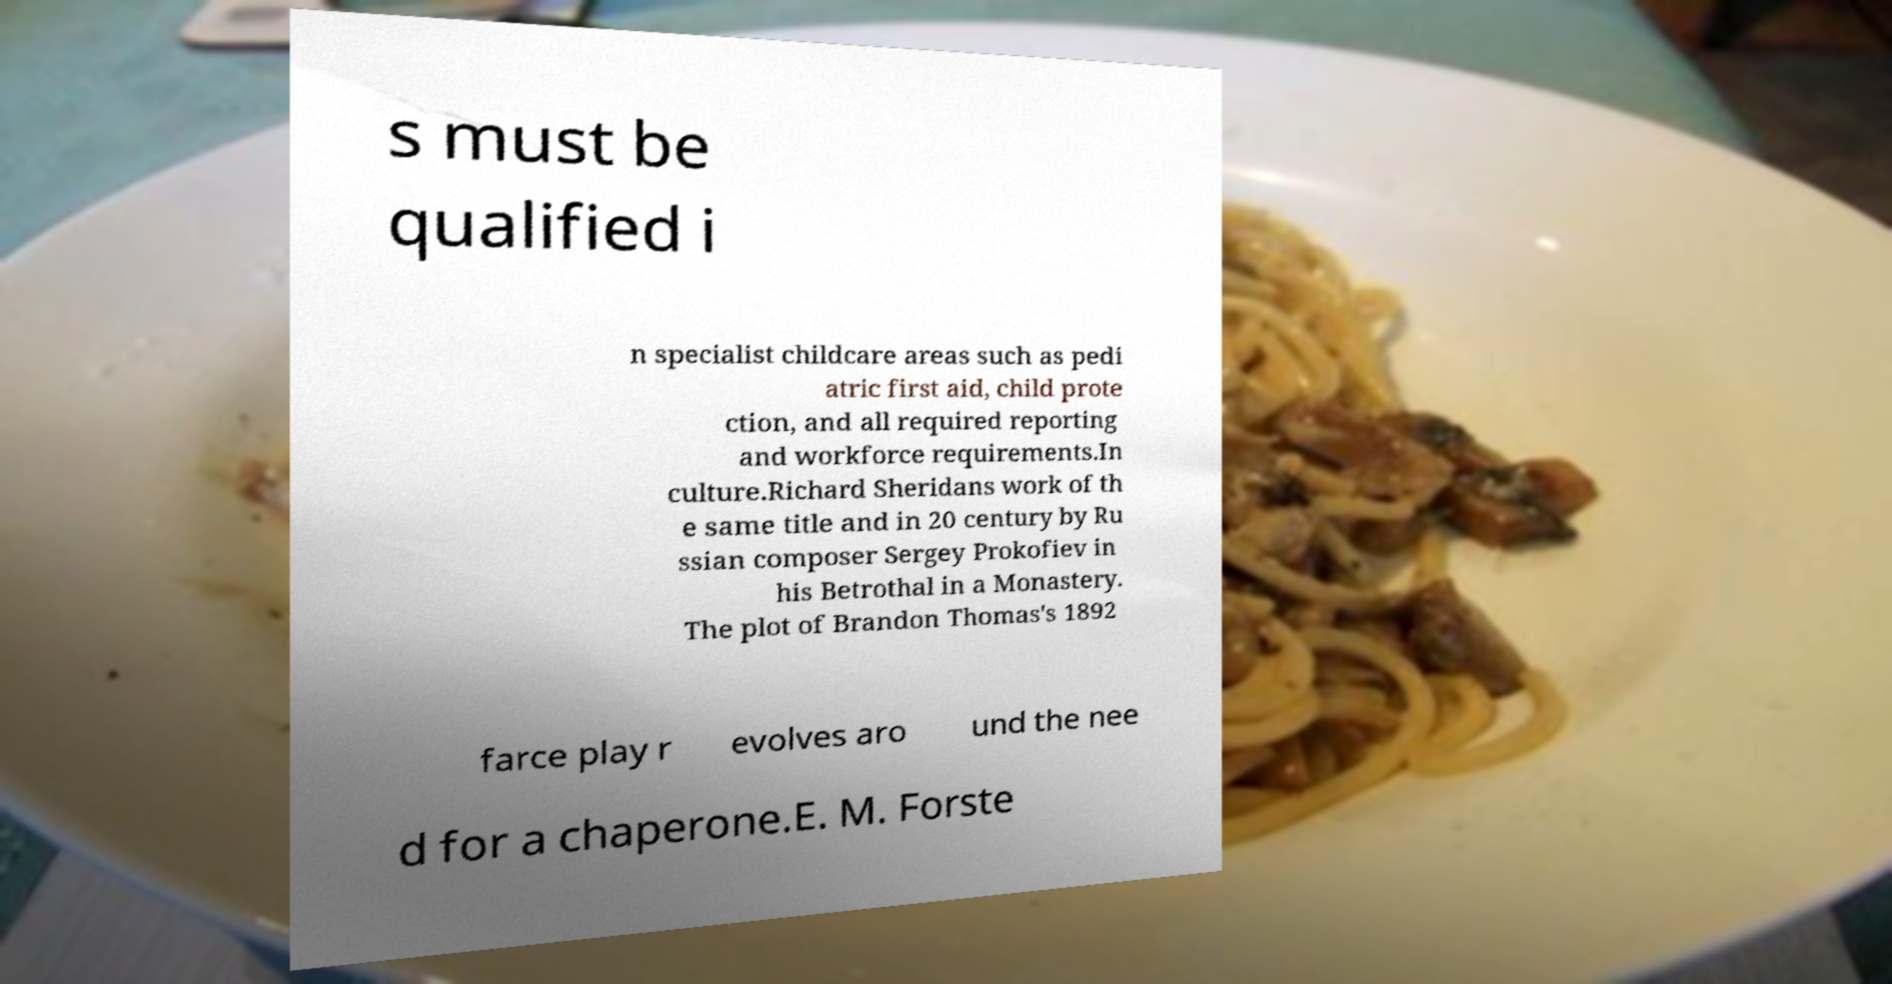I need the written content from this picture converted into text. Can you do that? s must be qualified i n specialist childcare areas such as pedi atric first aid, child prote ction, and all required reporting and workforce requirements.In culture.Richard Sheridans work of th e same title and in 20 century by Ru ssian composer Sergey Prokofiev in his Betrothal in a Monastery. The plot of Brandon Thomas's 1892 farce play r evolves aro und the nee d for a chaperone.E. M. Forste 